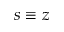<formula> <loc_0><loc_0><loc_500><loc_500>s \equiv z</formula> 